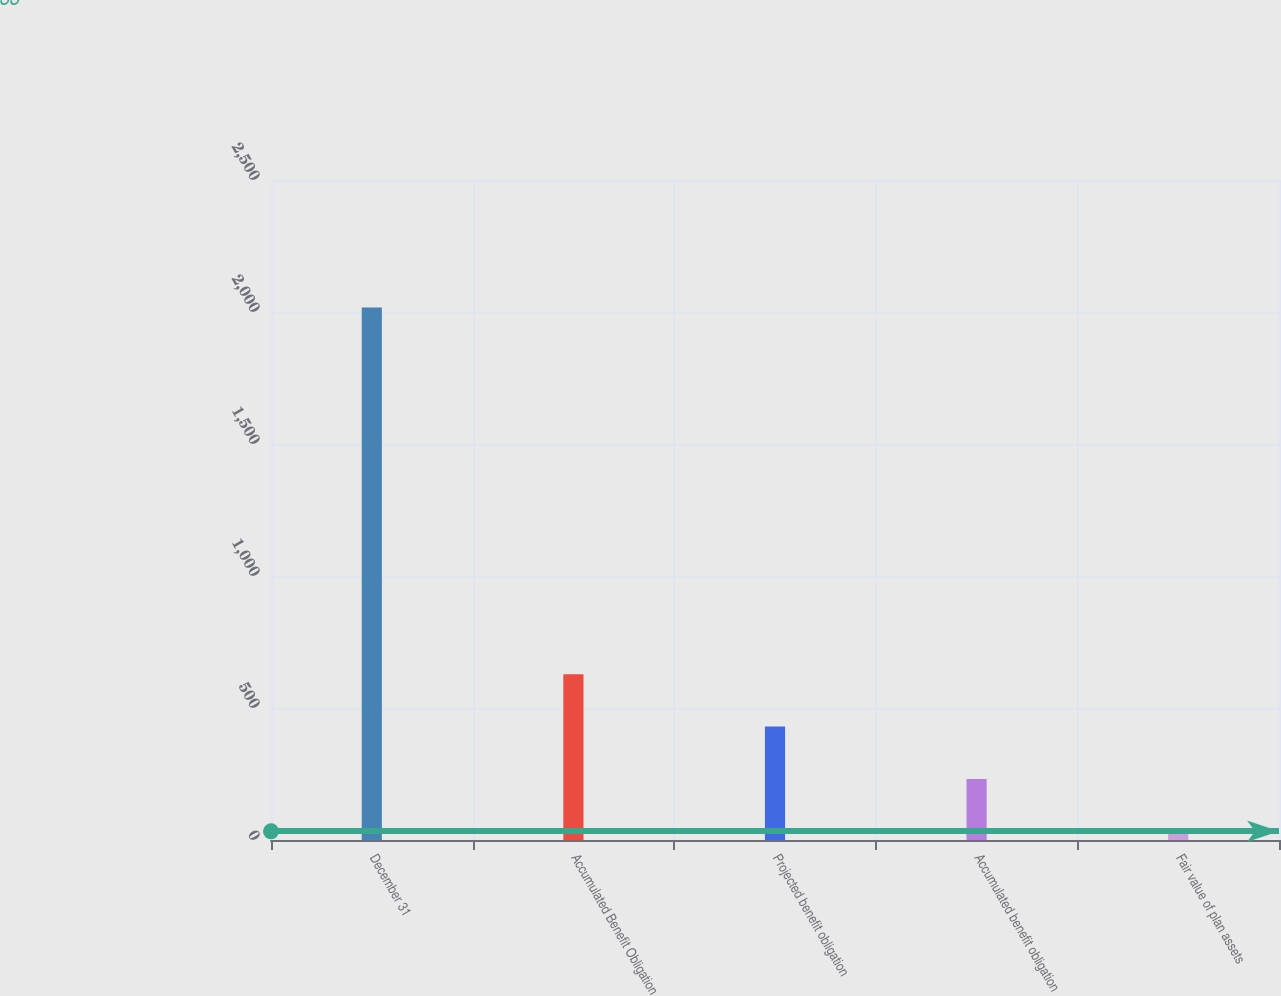<chart> <loc_0><loc_0><loc_500><loc_500><bar_chart><fcel>December 31<fcel>Accumulated Benefit Obligation<fcel>Projected benefit obligation<fcel>Accumulated benefit obligation<fcel>Fair value of plan assets<nl><fcel>2017<fcel>628.2<fcel>429.8<fcel>231.4<fcel>33<nl></chart> 